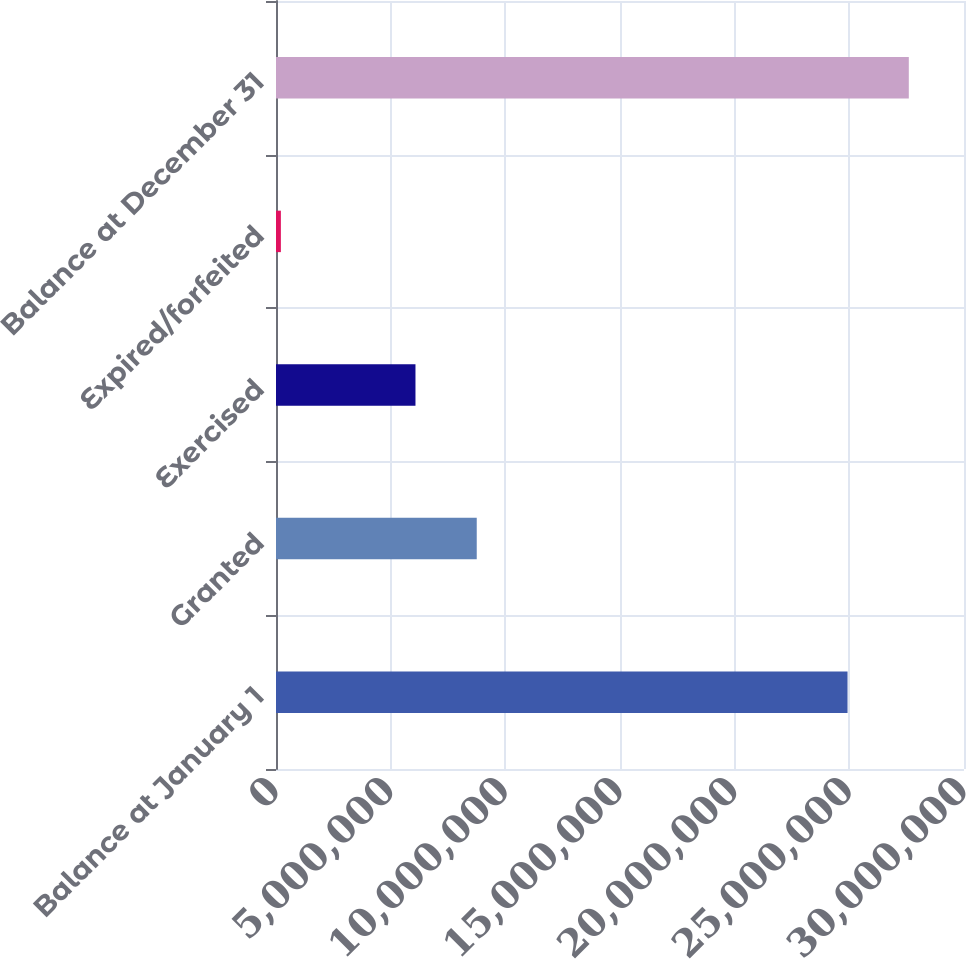Convert chart to OTSL. <chart><loc_0><loc_0><loc_500><loc_500><bar_chart><fcel>Balance at January 1<fcel>Granted<fcel>Exercised<fcel>Expired/forfeited<fcel>Balance at December 31<nl><fcel>2.49216e+07<fcel>8.75344e+06<fcel>6.08165e+06<fcel>212500<fcel>2.75934e+07<nl></chart> 